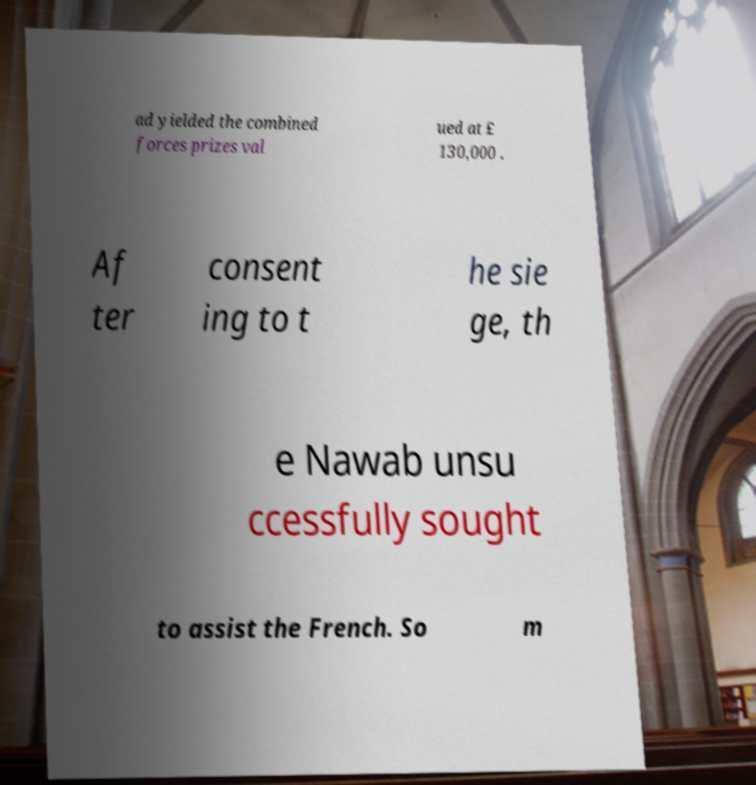There's text embedded in this image that I need extracted. Can you transcribe it verbatim? ad yielded the combined forces prizes val ued at £ 130,000 . Af ter consent ing to t he sie ge, th e Nawab unsu ccessfully sought to assist the French. So m 